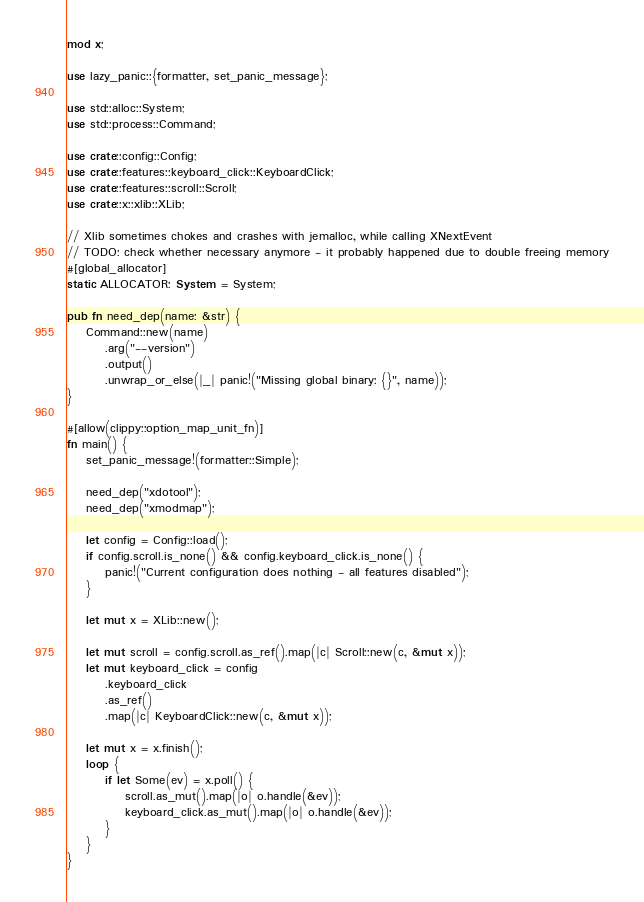<code> <loc_0><loc_0><loc_500><loc_500><_Rust_>mod x;

use lazy_panic::{formatter, set_panic_message};

use std::alloc::System;
use std::process::Command;

use crate::config::Config;
use crate::features::keyboard_click::KeyboardClick;
use crate::features::scroll::Scroll;
use crate::x::xlib::XLib;

// Xlib sometimes chokes and crashes with jemalloc, while calling XNextEvent
// TODO: check whether necessary anymore - it probably happened due to double freeing memory
#[global_allocator]
static ALLOCATOR: System = System;

pub fn need_dep(name: &str) {
    Command::new(name)
        .arg("--version")
        .output()
        .unwrap_or_else(|_| panic!("Missing global binary: {}", name));
}

#[allow(clippy::option_map_unit_fn)]
fn main() {
    set_panic_message!(formatter::Simple);

    need_dep("xdotool");
    need_dep("xmodmap");

    let config = Config::load();
    if config.scroll.is_none() && config.keyboard_click.is_none() {
        panic!("Current configuration does nothing - all features disabled");
    }

    let mut x = XLib::new();

    let mut scroll = config.scroll.as_ref().map(|c| Scroll::new(c, &mut x));
    let mut keyboard_click = config
        .keyboard_click
        .as_ref()
        .map(|c| KeyboardClick::new(c, &mut x));

    let mut x = x.finish();
    loop {
        if let Some(ev) = x.poll() {
            scroll.as_mut().map(|o| o.handle(&ev));
            keyboard_click.as_mut().map(|o| o.handle(&ev));
        }
    }
}
</code> 